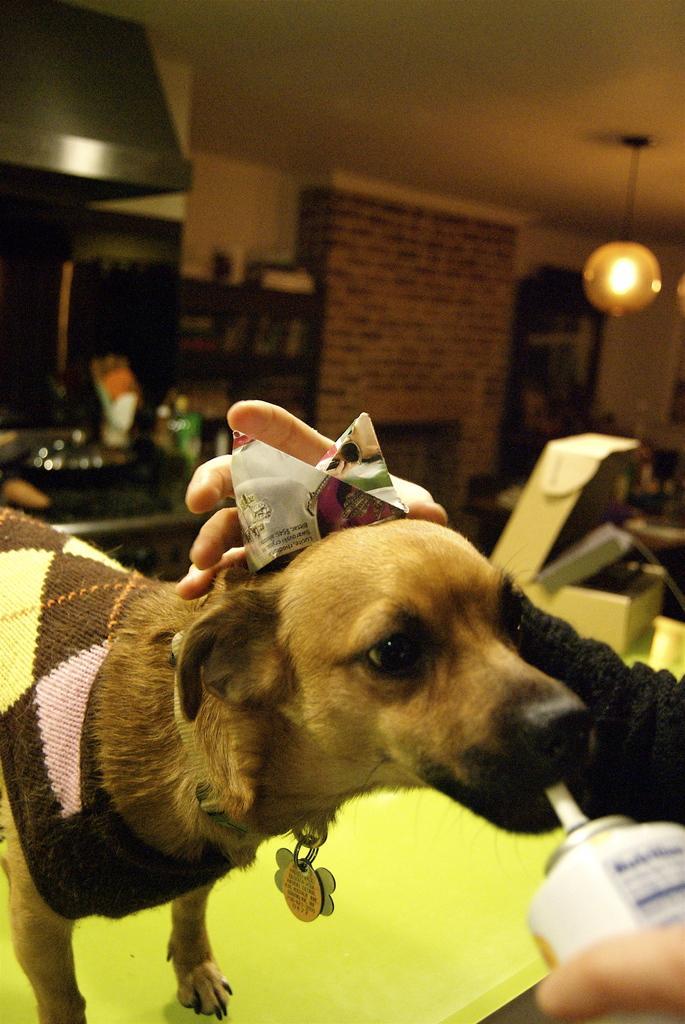Describe this image in one or two sentences. In the picture we can see a dog standing on the table and a person is made to drink something to the dog and holding the dog with the other hand and in the background, we can see a wall and near to it, we can see a desk with something are placed end to the ceiling we can see a lamp is hanged. 